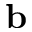<formula> <loc_0><loc_0><loc_500><loc_500>b</formula> 